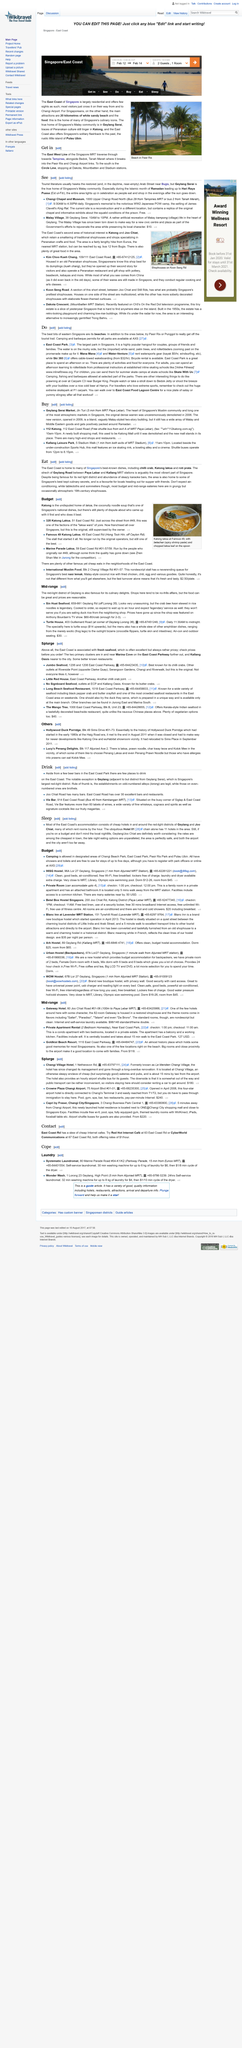List a handful of essential elements in this visual. Goldkist Beach Resort holds good memories for many Singaporeans who have visited the resort and experienced its warm hospitality and beautiful surroundings. The red-light districts in Singapore are Geylang and Joo Chiat. The restaurants in Singapore are characterized by their grungy, occasionally atmospheric, and 19th-century shophouse settings. There are only a few places to drink on the East Coast, and yes, they do exist. Geylang Serai is known as the true home of Singapore's Malay community. 